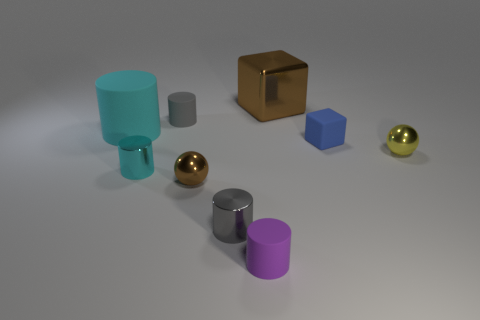Do the brown metallic thing that is on the right side of the purple cylinder and the tiny brown shiny ball have the same size?
Your response must be concise. No. What number of big objects are either cyan metal cylinders or purple cylinders?
Your response must be concise. 0. Are there any tiny rubber blocks of the same color as the large metallic thing?
Keep it short and to the point. No. What is the shape of the yellow object that is the same size as the cyan metal cylinder?
Give a very brief answer. Sphere. Is the color of the big thing that is behind the cyan matte thing the same as the tiny block?
Keep it short and to the point. No. How many objects are either tiny matte objects right of the tiny gray rubber object or large objects?
Offer a very short reply. 4. Are there more tiny metallic balls right of the big shiny object than tiny purple rubber objects that are on the left side of the small gray metal thing?
Offer a terse response. Yes. Does the large cyan cylinder have the same material as the large brown thing?
Provide a succinct answer. No. The tiny thing that is on the left side of the brown cube and right of the gray metallic cylinder has what shape?
Your answer should be compact. Cylinder. The tiny cyan object that is made of the same material as the big brown block is what shape?
Your answer should be very brief. Cylinder. 